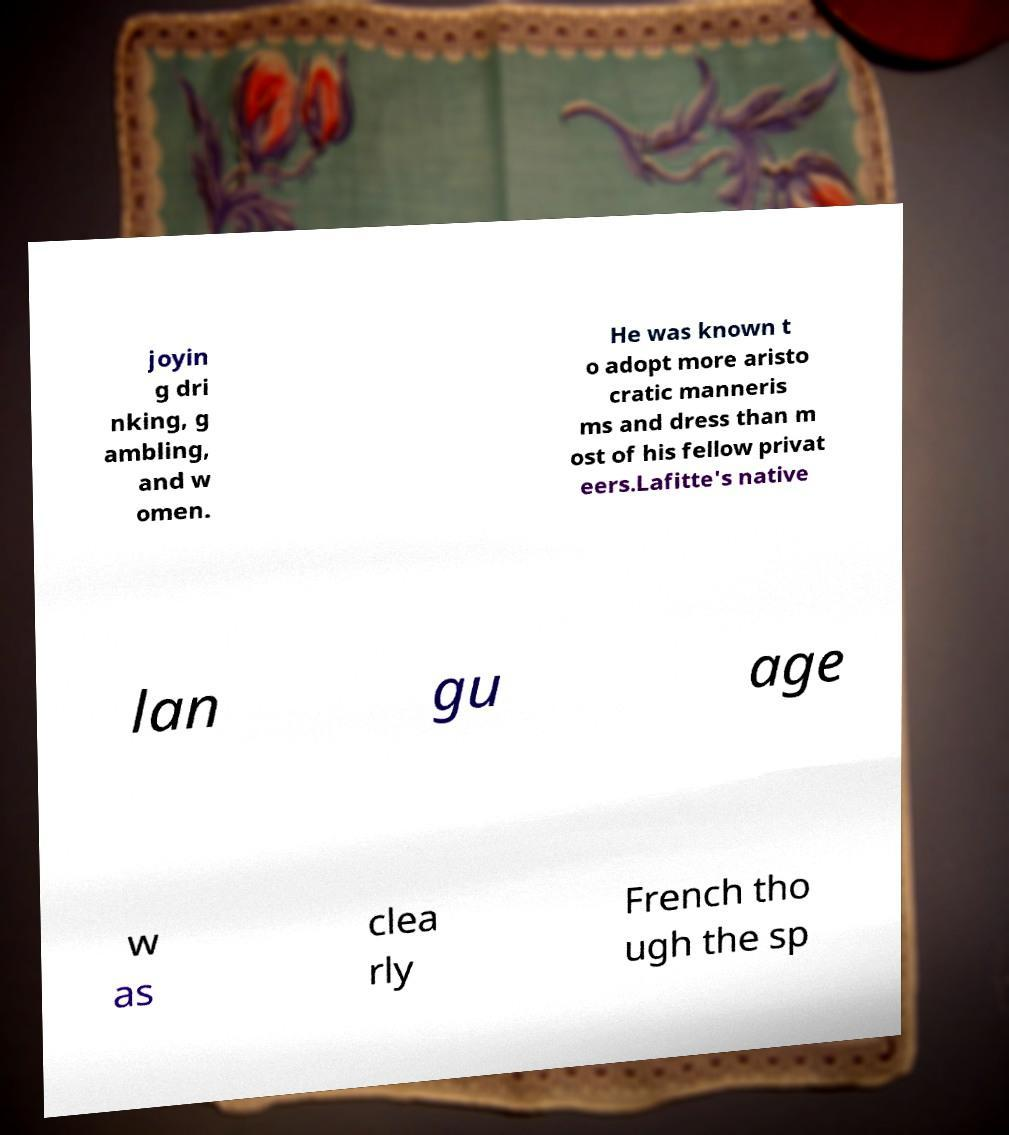I need the written content from this picture converted into text. Can you do that? joyin g dri nking, g ambling, and w omen. He was known t o adopt more aristo cratic manneris ms and dress than m ost of his fellow privat eers.Lafitte's native lan gu age w as clea rly French tho ugh the sp 